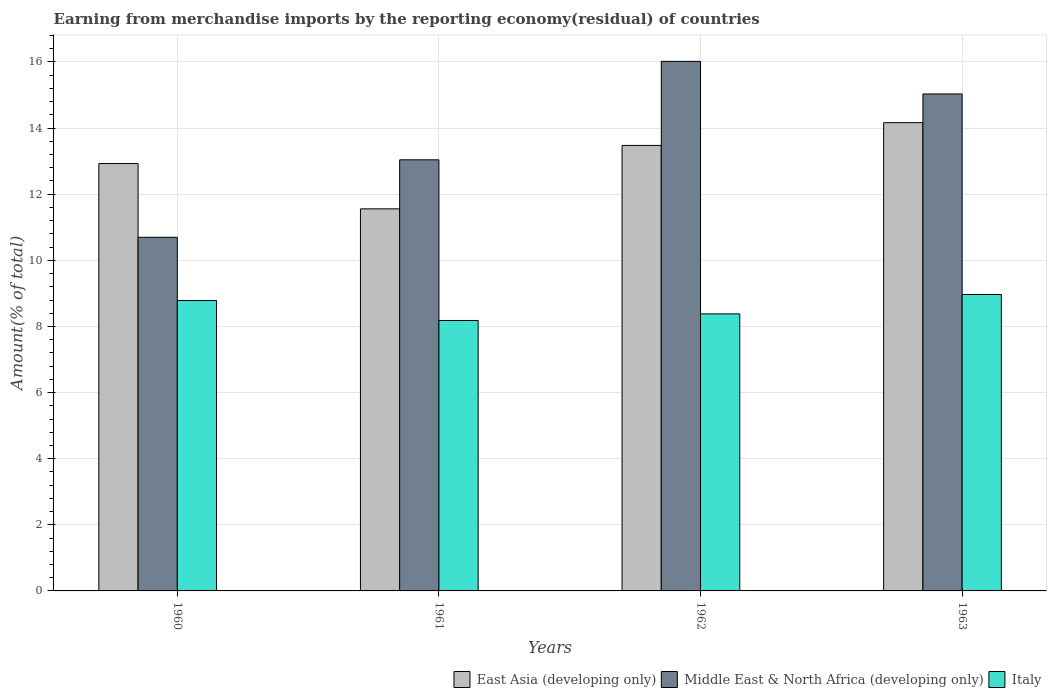Are the number of bars per tick equal to the number of legend labels?
Give a very brief answer. Yes. Are the number of bars on each tick of the X-axis equal?
Provide a succinct answer. Yes. How many bars are there on the 2nd tick from the left?
Give a very brief answer. 3. How many bars are there on the 2nd tick from the right?
Offer a terse response. 3. What is the label of the 3rd group of bars from the left?
Provide a succinct answer. 1962. In how many cases, is the number of bars for a given year not equal to the number of legend labels?
Offer a very short reply. 0. What is the percentage of amount earned from merchandise imports in Middle East & North Africa (developing only) in 1963?
Give a very brief answer. 15.03. Across all years, what is the maximum percentage of amount earned from merchandise imports in East Asia (developing only)?
Your answer should be very brief. 14.16. Across all years, what is the minimum percentage of amount earned from merchandise imports in Middle East & North Africa (developing only)?
Give a very brief answer. 10.7. In which year was the percentage of amount earned from merchandise imports in Italy maximum?
Offer a terse response. 1963. What is the total percentage of amount earned from merchandise imports in Middle East & North Africa (developing only) in the graph?
Give a very brief answer. 54.79. What is the difference between the percentage of amount earned from merchandise imports in Italy in 1961 and that in 1963?
Ensure brevity in your answer.  -0.79. What is the difference between the percentage of amount earned from merchandise imports in East Asia (developing only) in 1963 and the percentage of amount earned from merchandise imports in Middle East & North Africa (developing only) in 1960?
Make the answer very short. 3.47. What is the average percentage of amount earned from merchandise imports in Italy per year?
Provide a succinct answer. 8.58. In the year 1963, what is the difference between the percentage of amount earned from merchandise imports in Middle East & North Africa (developing only) and percentage of amount earned from merchandise imports in East Asia (developing only)?
Ensure brevity in your answer.  0.87. What is the ratio of the percentage of amount earned from merchandise imports in East Asia (developing only) in 1960 to that in 1963?
Your response must be concise. 0.91. What is the difference between the highest and the second highest percentage of amount earned from merchandise imports in East Asia (developing only)?
Offer a terse response. 0.69. What is the difference between the highest and the lowest percentage of amount earned from merchandise imports in Italy?
Keep it short and to the point. 0.79. In how many years, is the percentage of amount earned from merchandise imports in Italy greater than the average percentage of amount earned from merchandise imports in Italy taken over all years?
Make the answer very short. 2. What does the 3rd bar from the left in 1962 represents?
Ensure brevity in your answer.  Italy. What does the 2nd bar from the right in 1962 represents?
Provide a succinct answer. Middle East & North Africa (developing only). Is it the case that in every year, the sum of the percentage of amount earned from merchandise imports in Middle East & North Africa (developing only) and percentage of amount earned from merchandise imports in Italy is greater than the percentage of amount earned from merchandise imports in East Asia (developing only)?
Ensure brevity in your answer.  Yes. Are all the bars in the graph horizontal?
Your answer should be compact. No. Where does the legend appear in the graph?
Provide a short and direct response. Bottom right. How many legend labels are there?
Your response must be concise. 3. What is the title of the graph?
Give a very brief answer. Earning from merchandise imports by the reporting economy(residual) of countries. What is the label or title of the Y-axis?
Ensure brevity in your answer.  Amount(% of total). What is the Amount(% of total) of East Asia (developing only) in 1960?
Provide a succinct answer. 12.93. What is the Amount(% of total) of Middle East & North Africa (developing only) in 1960?
Provide a succinct answer. 10.7. What is the Amount(% of total) in Italy in 1960?
Make the answer very short. 8.78. What is the Amount(% of total) of East Asia (developing only) in 1961?
Offer a very short reply. 11.56. What is the Amount(% of total) in Middle East & North Africa (developing only) in 1961?
Provide a succinct answer. 13.04. What is the Amount(% of total) in Italy in 1961?
Make the answer very short. 8.18. What is the Amount(% of total) of East Asia (developing only) in 1962?
Make the answer very short. 13.48. What is the Amount(% of total) of Middle East & North Africa (developing only) in 1962?
Provide a short and direct response. 16.02. What is the Amount(% of total) of Italy in 1962?
Your response must be concise. 8.38. What is the Amount(% of total) of East Asia (developing only) in 1963?
Offer a very short reply. 14.16. What is the Amount(% of total) in Middle East & North Africa (developing only) in 1963?
Keep it short and to the point. 15.03. What is the Amount(% of total) of Italy in 1963?
Your response must be concise. 8.97. Across all years, what is the maximum Amount(% of total) in East Asia (developing only)?
Make the answer very short. 14.16. Across all years, what is the maximum Amount(% of total) in Middle East & North Africa (developing only)?
Give a very brief answer. 16.02. Across all years, what is the maximum Amount(% of total) in Italy?
Give a very brief answer. 8.97. Across all years, what is the minimum Amount(% of total) of East Asia (developing only)?
Ensure brevity in your answer.  11.56. Across all years, what is the minimum Amount(% of total) of Middle East & North Africa (developing only)?
Provide a short and direct response. 10.7. Across all years, what is the minimum Amount(% of total) of Italy?
Make the answer very short. 8.18. What is the total Amount(% of total) in East Asia (developing only) in the graph?
Your response must be concise. 52.13. What is the total Amount(% of total) in Middle East & North Africa (developing only) in the graph?
Ensure brevity in your answer.  54.79. What is the total Amount(% of total) of Italy in the graph?
Your answer should be very brief. 34.31. What is the difference between the Amount(% of total) of East Asia (developing only) in 1960 and that in 1961?
Give a very brief answer. 1.37. What is the difference between the Amount(% of total) in Middle East & North Africa (developing only) in 1960 and that in 1961?
Your answer should be compact. -2.34. What is the difference between the Amount(% of total) of Italy in 1960 and that in 1961?
Provide a succinct answer. 0.6. What is the difference between the Amount(% of total) in East Asia (developing only) in 1960 and that in 1962?
Ensure brevity in your answer.  -0.55. What is the difference between the Amount(% of total) in Middle East & North Africa (developing only) in 1960 and that in 1962?
Offer a terse response. -5.32. What is the difference between the Amount(% of total) in Italy in 1960 and that in 1962?
Offer a terse response. 0.4. What is the difference between the Amount(% of total) of East Asia (developing only) in 1960 and that in 1963?
Your answer should be compact. -1.24. What is the difference between the Amount(% of total) of Middle East & North Africa (developing only) in 1960 and that in 1963?
Offer a terse response. -4.34. What is the difference between the Amount(% of total) in Italy in 1960 and that in 1963?
Make the answer very short. -0.18. What is the difference between the Amount(% of total) of East Asia (developing only) in 1961 and that in 1962?
Provide a short and direct response. -1.92. What is the difference between the Amount(% of total) of Middle East & North Africa (developing only) in 1961 and that in 1962?
Make the answer very short. -2.98. What is the difference between the Amount(% of total) in Italy in 1961 and that in 1962?
Your answer should be compact. -0.2. What is the difference between the Amount(% of total) of East Asia (developing only) in 1961 and that in 1963?
Your answer should be very brief. -2.61. What is the difference between the Amount(% of total) in Middle East & North Africa (developing only) in 1961 and that in 1963?
Offer a terse response. -1.99. What is the difference between the Amount(% of total) in Italy in 1961 and that in 1963?
Your answer should be compact. -0.79. What is the difference between the Amount(% of total) of East Asia (developing only) in 1962 and that in 1963?
Keep it short and to the point. -0.69. What is the difference between the Amount(% of total) of Middle East & North Africa (developing only) in 1962 and that in 1963?
Give a very brief answer. 0.99. What is the difference between the Amount(% of total) of Italy in 1962 and that in 1963?
Make the answer very short. -0.59. What is the difference between the Amount(% of total) of East Asia (developing only) in 1960 and the Amount(% of total) of Middle East & North Africa (developing only) in 1961?
Offer a terse response. -0.11. What is the difference between the Amount(% of total) in East Asia (developing only) in 1960 and the Amount(% of total) in Italy in 1961?
Keep it short and to the point. 4.75. What is the difference between the Amount(% of total) in Middle East & North Africa (developing only) in 1960 and the Amount(% of total) in Italy in 1961?
Keep it short and to the point. 2.52. What is the difference between the Amount(% of total) of East Asia (developing only) in 1960 and the Amount(% of total) of Middle East & North Africa (developing only) in 1962?
Your answer should be very brief. -3.09. What is the difference between the Amount(% of total) of East Asia (developing only) in 1960 and the Amount(% of total) of Italy in 1962?
Your answer should be compact. 4.55. What is the difference between the Amount(% of total) in Middle East & North Africa (developing only) in 1960 and the Amount(% of total) in Italy in 1962?
Make the answer very short. 2.32. What is the difference between the Amount(% of total) of East Asia (developing only) in 1960 and the Amount(% of total) of Middle East & North Africa (developing only) in 1963?
Your response must be concise. -2.1. What is the difference between the Amount(% of total) of East Asia (developing only) in 1960 and the Amount(% of total) of Italy in 1963?
Keep it short and to the point. 3.96. What is the difference between the Amount(% of total) of Middle East & North Africa (developing only) in 1960 and the Amount(% of total) of Italy in 1963?
Your answer should be very brief. 1.73. What is the difference between the Amount(% of total) in East Asia (developing only) in 1961 and the Amount(% of total) in Middle East & North Africa (developing only) in 1962?
Give a very brief answer. -4.46. What is the difference between the Amount(% of total) of East Asia (developing only) in 1961 and the Amount(% of total) of Italy in 1962?
Your answer should be very brief. 3.18. What is the difference between the Amount(% of total) in Middle East & North Africa (developing only) in 1961 and the Amount(% of total) in Italy in 1962?
Make the answer very short. 4.66. What is the difference between the Amount(% of total) of East Asia (developing only) in 1961 and the Amount(% of total) of Middle East & North Africa (developing only) in 1963?
Provide a succinct answer. -3.48. What is the difference between the Amount(% of total) of East Asia (developing only) in 1961 and the Amount(% of total) of Italy in 1963?
Provide a succinct answer. 2.59. What is the difference between the Amount(% of total) in Middle East & North Africa (developing only) in 1961 and the Amount(% of total) in Italy in 1963?
Provide a short and direct response. 4.07. What is the difference between the Amount(% of total) in East Asia (developing only) in 1962 and the Amount(% of total) in Middle East & North Africa (developing only) in 1963?
Your response must be concise. -1.56. What is the difference between the Amount(% of total) in East Asia (developing only) in 1962 and the Amount(% of total) in Italy in 1963?
Provide a succinct answer. 4.51. What is the difference between the Amount(% of total) of Middle East & North Africa (developing only) in 1962 and the Amount(% of total) of Italy in 1963?
Ensure brevity in your answer.  7.05. What is the average Amount(% of total) of East Asia (developing only) per year?
Your answer should be very brief. 13.03. What is the average Amount(% of total) in Middle East & North Africa (developing only) per year?
Your response must be concise. 13.7. What is the average Amount(% of total) in Italy per year?
Ensure brevity in your answer.  8.58. In the year 1960, what is the difference between the Amount(% of total) in East Asia (developing only) and Amount(% of total) in Middle East & North Africa (developing only)?
Give a very brief answer. 2.23. In the year 1960, what is the difference between the Amount(% of total) of East Asia (developing only) and Amount(% of total) of Italy?
Your answer should be very brief. 4.14. In the year 1960, what is the difference between the Amount(% of total) in Middle East & North Africa (developing only) and Amount(% of total) in Italy?
Provide a succinct answer. 1.91. In the year 1961, what is the difference between the Amount(% of total) in East Asia (developing only) and Amount(% of total) in Middle East & North Africa (developing only)?
Give a very brief answer. -1.48. In the year 1961, what is the difference between the Amount(% of total) in East Asia (developing only) and Amount(% of total) in Italy?
Your answer should be compact. 3.38. In the year 1961, what is the difference between the Amount(% of total) in Middle East & North Africa (developing only) and Amount(% of total) in Italy?
Ensure brevity in your answer.  4.86. In the year 1962, what is the difference between the Amount(% of total) in East Asia (developing only) and Amount(% of total) in Middle East & North Africa (developing only)?
Provide a short and direct response. -2.54. In the year 1962, what is the difference between the Amount(% of total) in East Asia (developing only) and Amount(% of total) in Italy?
Your answer should be very brief. 5.1. In the year 1962, what is the difference between the Amount(% of total) of Middle East & North Africa (developing only) and Amount(% of total) of Italy?
Offer a terse response. 7.64. In the year 1963, what is the difference between the Amount(% of total) of East Asia (developing only) and Amount(% of total) of Middle East & North Africa (developing only)?
Offer a very short reply. -0.87. In the year 1963, what is the difference between the Amount(% of total) in East Asia (developing only) and Amount(% of total) in Italy?
Keep it short and to the point. 5.2. In the year 1963, what is the difference between the Amount(% of total) in Middle East & North Africa (developing only) and Amount(% of total) in Italy?
Provide a short and direct response. 6.07. What is the ratio of the Amount(% of total) in East Asia (developing only) in 1960 to that in 1961?
Your response must be concise. 1.12. What is the ratio of the Amount(% of total) in Middle East & North Africa (developing only) in 1960 to that in 1961?
Make the answer very short. 0.82. What is the ratio of the Amount(% of total) of Italy in 1960 to that in 1961?
Ensure brevity in your answer.  1.07. What is the ratio of the Amount(% of total) in East Asia (developing only) in 1960 to that in 1962?
Your answer should be very brief. 0.96. What is the ratio of the Amount(% of total) of Middle East & North Africa (developing only) in 1960 to that in 1962?
Keep it short and to the point. 0.67. What is the ratio of the Amount(% of total) in Italy in 1960 to that in 1962?
Make the answer very short. 1.05. What is the ratio of the Amount(% of total) of East Asia (developing only) in 1960 to that in 1963?
Give a very brief answer. 0.91. What is the ratio of the Amount(% of total) of Middle East & North Africa (developing only) in 1960 to that in 1963?
Make the answer very short. 0.71. What is the ratio of the Amount(% of total) of Italy in 1960 to that in 1963?
Keep it short and to the point. 0.98. What is the ratio of the Amount(% of total) in East Asia (developing only) in 1961 to that in 1962?
Your response must be concise. 0.86. What is the ratio of the Amount(% of total) in Middle East & North Africa (developing only) in 1961 to that in 1962?
Your response must be concise. 0.81. What is the ratio of the Amount(% of total) in Italy in 1961 to that in 1962?
Give a very brief answer. 0.98. What is the ratio of the Amount(% of total) of East Asia (developing only) in 1961 to that in 1963?
Keep it short and to the point. 0.82. What is the ratio of the Amount(% of total) of Middle East & North Africa (developing only) in 1961 to that in 1963?
Your answer should be very brief. 0.87. What is the ratio of the Amount(% of total) of Italy in 1961 to that in 1963?
Keep it short and to the point. 0.91. What is the ratio of the Amount(% of total) of East Asia (developing only) in 1962 to that in 1963?
Offer a terse response. 0.95. What is the ratio of the Amount(% of total) of Middle East & North Africa (developing only) in 1962 to that in 1963?
Your response must be concise. 1.07. What is the ratio of the Amount(% of total) of Italy in 1962 to that in 1963?
Your answer should be compact. 0.93. What is the difference between the highest and the second highest Amount(% of total) of East Asia (developing only)?
Ensure brevity in your answer.  0.69. What is the difference between the highest and the second highest Amount(% of total) of Middle East & North Africa (developing only)?
Offer a terse response. 0.99. What is the difference between the highest and the second highest Amount(% of total) of Italy?
Keep it short and to the point. 0.18. What is the difference between the highest and the lowest Amount(% of total) of East Asia (developing only)?
Make the answer very short. 2.61. What is the difference between the highest and the lowest Amount(% of total) in Middle East & North Africa (developing only)?
Your answer should be compact. 5.32. What is the difference between the highest and the lowest Amount(% of total) of Italy?
Keep it short and to the point. 0.79. 